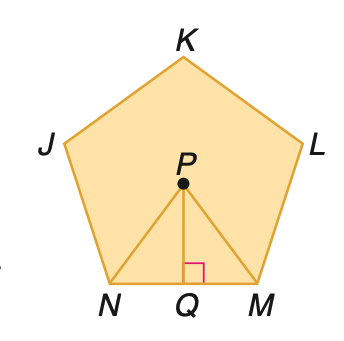Answer the mathemtical geometry problem and directly provide the correct option letter.
Question: Find the area of a regular pentagon with a perimeter of 40 centimeters.
Choices: A: 88 B: 110 C: 132 D: 160 B 